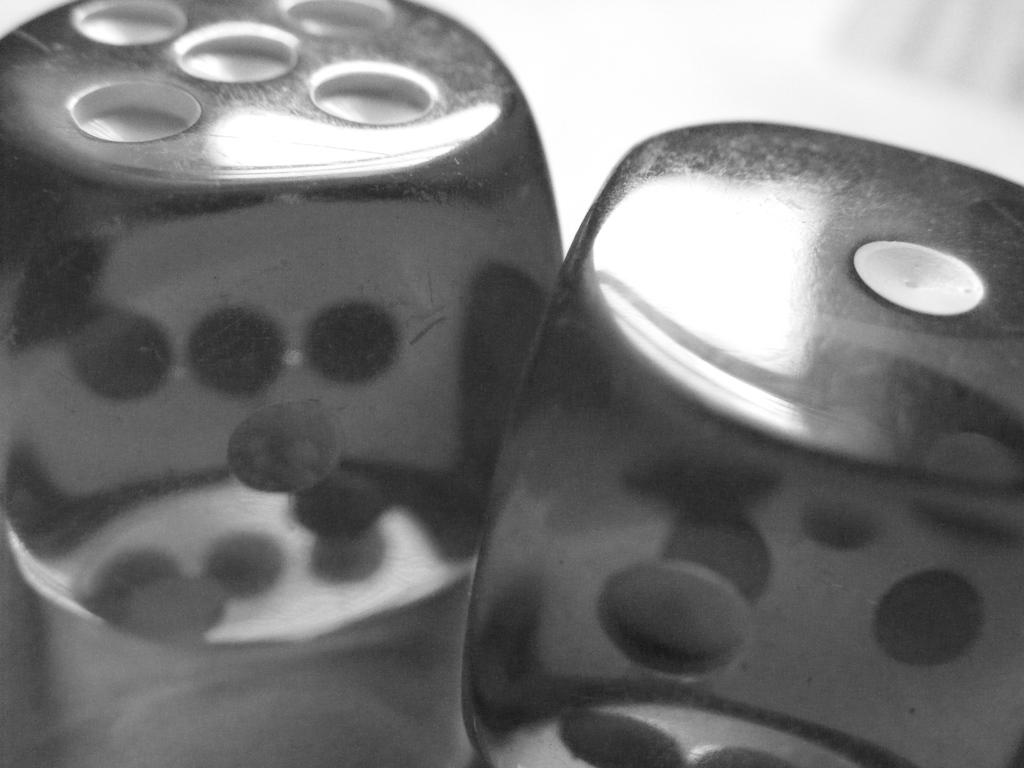What is the color scheme of the image? The image is black and white. What objects are present in the image? There are two dice in the image. Where are the dice located? The dice are on a surface. Reasoning: Leting: Let's think step by step in order to produce the conversation. We start by identifying the color scheme of the image, which is black and white. Then, we focus on the main objects in the image, which are the two dice. Finally, we describe the location of the dice, which are on a surface. Absurd Question/Answer: What type of cake is being served in the image? There is no cake present in the image; it features two dice on a surface. How many stars can be seen in the image? There are no stars visible in the image. What type of mist is present in the image? There is no mist present in the image; it features two dice on a surface. 